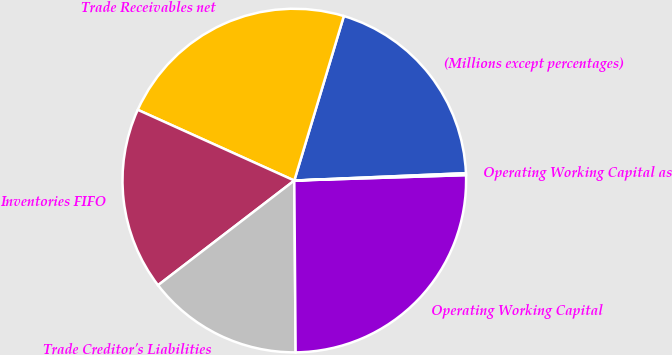Convert chart to OTSL. <chart><loc_0><loc_0><loc_500><loc_500><pie_chart><fcel>(Millions except percentages)<fcel>Trade Receivables net<fcel>Inventories FIFO<fcel>Trade Creditor's Liabilities<fcel>Operating Working Capital<fcel>Operating Working Capital as<nl><fcel>19.66%<fcel>22.9%<fcel>17.18%<fcel>14.7%<fcel>25.38%<fcel>0.18%<nl></chart> 